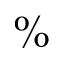Convert formula to latex. <formula><loc_0><loc_0><loc_500><loc_500>\%</formula> 